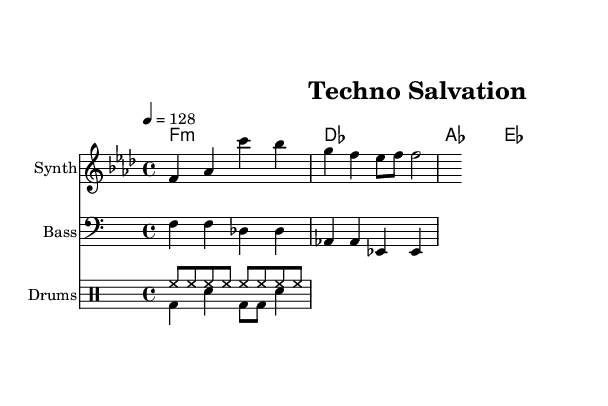What is the key signature of this music? The key signature indicates that there are four flats, representing F minor. This can be identified by looking at the beginning of the score where the flats are placed.
Answer: F minor What is the time signature of this piece? The time signature is indicated in the notation at the beginning of the piece, which shows a 4/4 time signature. This means there are four beats in each measure.
Answer: 4/4 What is the tempo marking given for this piece? The tempo marking is found at the start of the score, showing '4 = 128'. This indicates that a quarter note gets a tempo of 128 beats per minute.
Answer: 128 How many measures are in the melody section? By counting the groups of bars or slashes in the melody part, there are a total of 2 measures present in this segment of the score.
Answer: 2 What type of harmonies are used in the piece? The harmonies presented in the score utilize a chord progression with specific chord types shown in the chord names, which include major and minor chords typical in contemporary gospel music.
Answer: F minor, D flat, A flat, E flat Which instruments are indicated in the score? The instruments are listed at the beginning of each staff, including Synth for the melody, Bass for the bass line, and Drums for the percussion. This classification helps the performer understand their role.
Answer: Synth, Bass, Drums What influences can be seen in the music structure? The combination of gospel chord progressions and a techno rhythm pattern reflects the underground electronic influences marked by the drum patterns and harmony. Observing both the driving beat and spiritual elements in the melody indicates this fusion.
Answer: Gospel, techno 